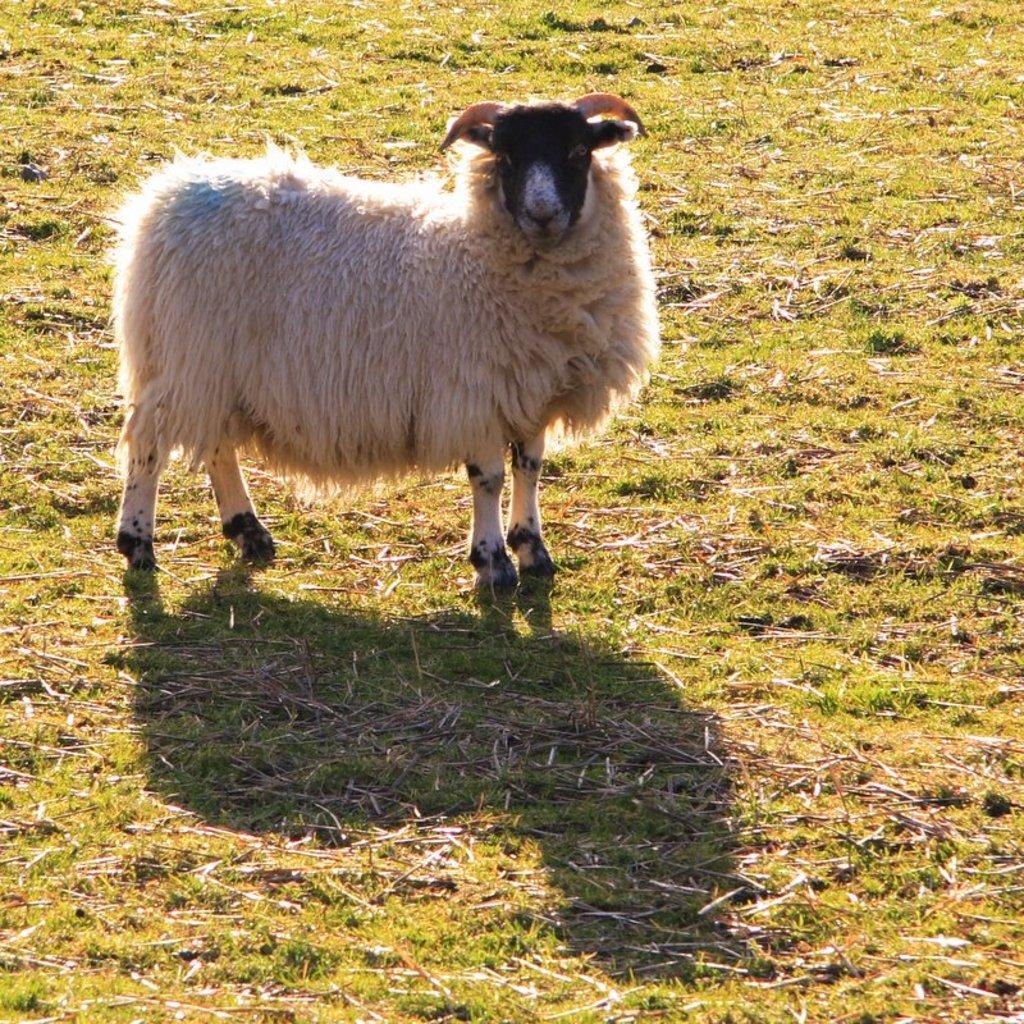What type of animal is in the image? There is a sheep in the image. What is the ground covered with? The ground is covered with grass. What objects made of wood can be seen in the image? There are wooden sticks in the image. Can you describe any other feature in the image besides the sheep and wooden sticks? The image shows a shadow on the ground. What type of yarn is the sheep using to knit a sweater in the image? There is no yarn or sweater present in the image; the sheep is simply standing on grass with wooden sticks nearby. 